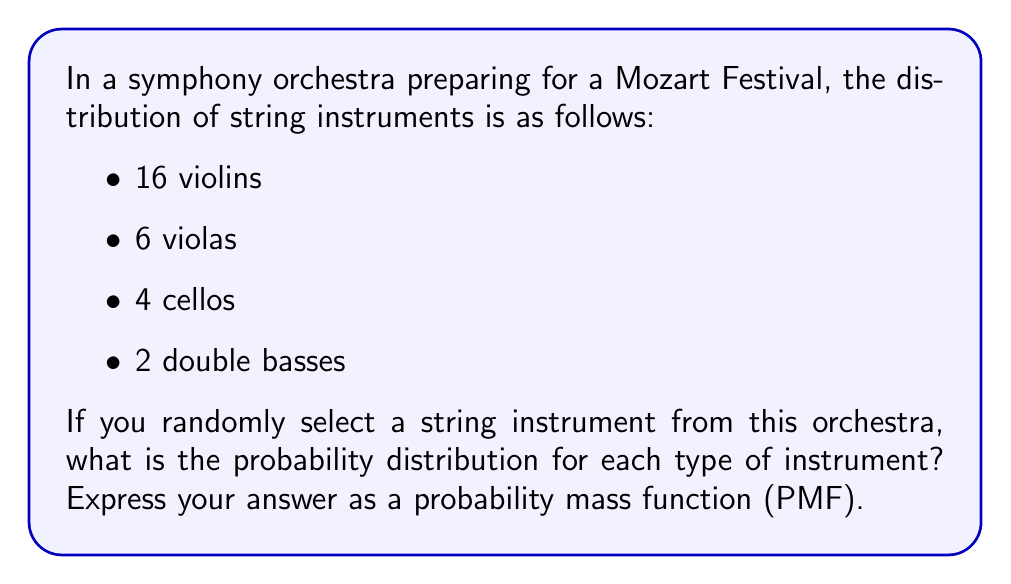Show me your answer to this math problem. To solve this problem, we'll follow these steps:

1. Calculate the total number of string instruments:
   $$\text{Total} = 16 + 6 + 4 + 2 = 28$$

2. Calculate the probability for each instrument type:

   For violins:
   $$P(\text{violin}) = \frac{16}{28} = \frac{4}{7}$$

   For violas:
   $$P(\text{viola}) = \frac{6}{28} = \frac{3}{14}$$

   For cellos:
   $$P(\text{cello}) = \frac{4}{28} = \frac{1}{7}$$

   For double basses:
   $$P(\text{double bass}) = \frac{2}{28} = \frac{1}{14}$$

3. Express the probability mass function (PMF):

   $$P(X = x) = \begin{cases}
   \frac{4}{7}, & \text{if } x = \text{violin} \\
   \frac{3}{14}, & \text{if } x = \text{viola} \\
   \frac{1}{7}, & \text{if } x = \text{cello} \\
   \frac{1}{14}, & \text{if } x = \text{double bass} \\
   0, & \text{otherwise}
   \end{cases}$$

This PMF gives the probability of selecting each type of string instrument randomly from the orchestra.
Answer: $$P(X = x) = \begin{cases}
\frac{4}{7}, & \text{if } x = \text{violin} \\
\frac{3}{14}, & \text{if } x = \text{viola} \\
\frac{1}{7}, & \text{if } x = \text{cello} \\
\frac{1}{14}, & \text{if } x = \text{double bass} \\
0, & \text{otherwise}
\end{cases}$$ 